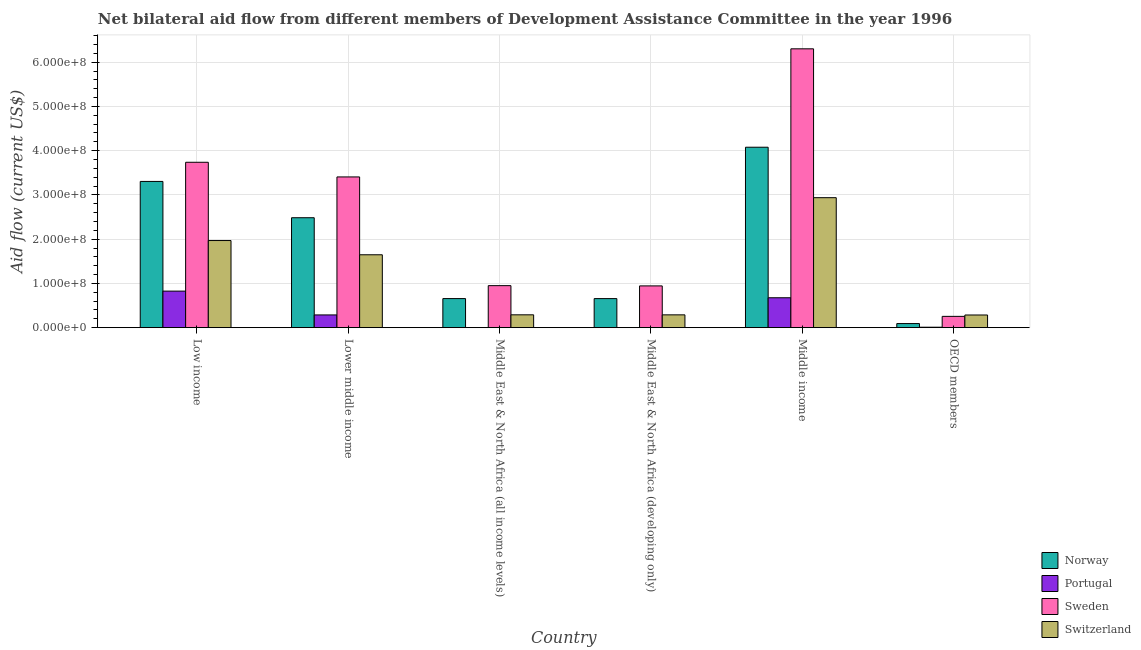How many different coloured bars are there?
Your answer should be very brief. 4. How many groups of bars are there?
Make the answer very short. 6. Are the number of bars per tick equal to the number of legend labels?
Make the answer very short. Yes. How many bars are there on the 5th tick from the left?
Make the answer very short. 4. How many bars are there on the 5th tick from the right?
Offer a terse response. 4. What is the label of the 5th group of bars from the left?
Your response must be concise. Middle income. What is the amount of aid given by switzerland in Middle income?
Give a very brief answer. 2.94e+08. Across all countries, what is the maximum amount of aid given by sweden?
Keep it short and to the point. 6.30e+08. Across all countries, what is the minimum amount of aid given by switzerland?
Offer a very short reply. 2.86e+07. In which country was the amount of aid given by portugal minimum?
Provide a succinct answer. Middle East & North Africa (all income levels). What is the total amount of aid given by sweden in the graph?
Offer a very short reply. 1.56e+09. What is the difference between the amount of aid given by sweden in Lower middle income and that in OECD members?
Provide a succinct answer. 3.15e+08. What is the difference between the amount of aid given by switzerland in Low income and the amount of aid given by norway in Middle East & North Africa (developing only)?
Your answer should be compact. 1.31e+08. What is the average amount of aid given by switzerland per country?
Your response must be concise. 1.24e+08. What is the difference between the amount of aid given by sweden and amount of aid given by norway in Lower middle income?
Ensure brevity in your answer.  9.22e+07. In how many countries, is the amount of aid given by sweden greater than 320000000 US$?
Your answer should be very brief. 3. What is the ratio of the amount of aid given by switzerland in Middle East & North Africa (all income levels) to that in OECD members?
Provide a succinct answer. 1.01. Is the difference between the amount of aid given by sweden in Middle East & North Africa (all income levels) and Middle income greater than the difference between the amount of aid given by switzerland in Middle East & North Africa (all income levels) and Middle income?
Offer a very short reply. No. What is the difference between the highest and the second highest amount of aid given by norway?
Provide a succinct answer. 7.73e+07. What is the difference between the highest and the lowest amount of aid given by norway?
Provide a short and direct response. 3.98e+08. Is it the case that in every country, the sum of the amount of aid given by switzerland and amount of aid given by portugal is greater than the sum of amount of aid given by norway and amount of aid given by sweden?
Offer a very short reply. No. What does the 1st bar from the left in Lower middle income represents?
Ensure brevity in your answer.  Norway. What does the 1st bar from the right in Low income represents?
Provide a short and direct response. Switzerland. How many bars are there?
Ensure brevity in your answer.  24. Are all the bars in the graph horizontal?
Offer a terse response. No. What is the difference between two consecutive major ticks on the Y-axis?
Your response must be concise. 1.00e+08. Are the values on the major ticks of Y-axis written in scientific E-notation?
Ensure brevity in your answer.  Yes. Does the graph contain grids?
Offer a terse response. Yes. Where does the legend appear in the graph?
Your response must be concise. Bottom right. How are the legend labels stacked?
Your response must be concise. Vertical. What is the title of the graph?
Your response must be concise. Net bilateral aid flow from different members of Development Assistance Committee in the year 1996. What is the Aid flow (current US$) of Norway in Low income?
Your answer should be compact. 3.30e+08. What is the Aid flow (current US$) in Portugal in Low income?
Ensure brevity in your answer.  8.26e+07. What is the Aid flow (current US$) of Sweden in Low income?
Give a very brief answer. 3.74e+08. What is the Aid flow (current US$) in Switzerland in Low income?
Your response must be concise. 1.97e+08. What is the Aid flow (current US$) of Norway in Lower middle income?
Make the answer very short. 2.48e+08. What is the Aid flow (current US$) of Portugal in Lower middle income?
Ensure brevity in your answer.  2.88e+07. What is the Aid flow (current US$) in Sweden in Lower middle income?
Your answer should be compact. 3.41e+08. What is the Aid flow (current US$) in Switzerland in Lower middle income?
Your answer should be compact. 1.65e+08. What is the Aid flow (current US$) in Norway in Middle East & North Africa (all income levels)?
Give a very brief answer. 6.57e+07. What is the Aid flow (current US$) in Sweden in Middle East & North Africa (all income levels)?
Offer a very short reply. 9.50e+07. What is the Aid flow (current US$) of Switzerland in Middle East & North Africa (all income levels)?
Make the answer very short. 2.90e+07. What is the Aid flow (current US$) in Norway in Middle East & North Africa (developing only)?
Provide a short and direct response. 6.57e+07. What is the Aid flow (current US$) in Portugal in Middle East & North Africa (developing only)?
Give a very brief answer. 2.20e+05. What is the Aid flow (current US$) in Sweden in Middle East & North Africa (developing only)?
Your answer should be compact. 9.44e+07. What is the Aid flow (current US$) of Switzerland in Middle East & North Africa (developing only)?
Make the answer very short. 2.90e+07. What is the Aid flow (current US$) of Norway in Middle income?
Keep it short and to the point. 4.08e+08. What is the Aid flow (current US$) in Portugal in Middle income?
Provide a succinct answer. 6.76e+07. What is the Aid flow (current US$) of Sweden in Middle income?
Keep it short and to the point. 6.30e+08. What is the Aid flow (current US$) of Switzerland in Middle income?
Keep it short and to the point. 2.94e+08. What is the Aid flow (current US$) in Norway in OECD members?
Ensure brevity in your answer.  9.26e+06. What is the Aid flow (current US$) in Portugal in OECD members?
Provide a succinct answer. 1.03e+06. What is the Aid flow (current US$) of Sweden in OECD members?
Keep it short and to the point. 2.55e+07. What is the Aid flow (current US$) in Switzerland in OECD members?
Give a very brief answer. 2.86e+07. Across all countries, what is the maximum Aid flow (current US$) of Norway?
Give a very brief answer. 4.08e+08. Across all countries, what is the maximum Aid flow (current US$) of Portugal?
Offer a very short reply. 8.26e+07. Across all countries, what is the maximum Aid flow (current US$) of Sweden?
Offer a very short reply. 6.30e+08. Across all countries, what is the maximum Aid flow (current US$) in Switzerland?
Your answer should be very brief. 2.94e+08. Across all countries, what is the minimum Aid flow (current US$) in Norway?
Ensure brevity in your answer.  9.26e+06. Across all countries, what is the minimum Aid flow (current US$) in Sweden?
Provide a succinct answer. 2.55e+07. Across all countries, what is the minimum Aid flow (current US$) of Switzerland?
Make the answer very short. 2.86e+07. What is the total Aid flow (current US$) in Norway in the graph?
Provide a short and direct response. 1.13e+09. What is the total Aid flow (current US$) in Portugal in the graph?
Provide a short and direct response. 1.80e+08. What is the total Aid flow (current US$) of Sweden in the graph?
Provide a succinct answer. 1.56e+09. What is the total Aid flow (current US$) in Switzerland in the graph?
Give a very brief answer. 7.42e+08. What is the difference between the Aid flow (current US$) of Norway in Low income and that in Lower middle income?
Your answer should be very brief. 8.20e+07. What is the difference between the Aid flow (current US$) of Portugal in Low income and that in Lower middle income?
Your response must be concise. 5.38e+07. What is the difference between the Aid flow (current US$) in Sweden in Low income and that in Lower middle income?
Your answer should be very brief. 3.32e+07. What is the difference between the Aid flow (current US$) of Switzerland in Low income and that in Lower middle income?
Your response must be concise. 3.22e+07. What is the difference between the Aid flow (current US$) of Norway in Low income and that in Middle East & North Africa (all income levels)?
Offer a very short reply. 2.65e+08. What is the difference between the Aid flow (current US$) of Portugal in Low income and that in Middle East & North Africa (all income levels)?
Offer a terse response. 8.24e+07. What is the difference between the Aid flow (current US$) of Sweden in Low income and that in Middle East & North Africa (all income levels)?
Make the answer very short. 2.79e+08. What is the difference between the Aid flow (current US$) of Switzerland in Low income and that in Middle East & North Africa (all income levels)?
Offer a very short reply. 1.68e+08. What is the difference between the Aid flow (current US$) in Norway in Low income and that in Middle East & North Africa (developing only)?
Provide a succinct answer. 2.65e+08. What is the difference between the Aid flow (current US$) of Portugal in Low income and that in Middle East & North Africa (developing only)?
Keep it short and to the point. 8.24e+07. What is the difference between the Aid flow (current US$) in Sweden in Low income and that in Middle East & North Africa (developing only)?
Offer a very short reply. 2.79e+08. What is the difference between the Aid flow (current US$) of Switzerland in Low income and that in Middle East & North Africa (developing only)?
Your response must be concise. 1.68e+08. What is the difference between the Aid flow (current US$) of Norway in Low income and that in Middle income?
Provide a short and direct response. -7.73e+07. What is the difference between the Aid flow (current US$) in Portugal in Low income and that in Middle income?
Give a very brief answer. 1.50e+07. What is the difference between the Aid flow (current US$) in Sweden in Low income and that in Middle income?
Make the answer very short. -2.56e+08. What is the difference between the Aid flow (current US$) in Switzerland in Low income and that in Middle income?
Offer a very short reply. -9.68e+07. What is the difference between the Aid flow (current US$) of Norway in Low income and that in OECD members?
Make the answer very short. 3.21e+08. What is the difference between the Aid flow (current US$) in Portugal in Low income and that in OECD members?
Provide a short and direct response. 8.16e+07. What is the difference between the Aid flow (current US$) of Sweden in Low income and that in OECD members?
Ensure brevity in your answer.  3.48e+08. What is the difference between the Aid flow (current US$) of Switzerland in Low income and that in OECD members?
Provide a succinct answer. 1.68e+08. What is the difference between the Aid flow (current US$) in Norway in Lower middle income and that in Middle East & North Africa (all income levels)?
Keep it short and to the point. 1.83e+08. What is the difference between the Aid flow (current US$) of Portugal in Lower middle income and that in Middle East & North Africa (all income levels)?
Provide a succinct answer. 2.86e+07. What is the difference between the Aid flow (current US$) in Sweden in Lower middle income and that in Middle East & North Africa (all income levels)?
Ensure brevity in your answer.  2.46e+08. What is the difference between the Aid flow (current US$) of Switzerland in Lower middle income and that in Middle East & North Africa (all income levels)?
Provide a succinct answer. 1.36e+08. What is the difference between the Aid flow (current US$) of Norway in Lower middle income and that in Middle East & North Africa (developing only)?
Ensure brevity in your answer.  1.83e+08. What is the difference between the Aid flow (current US$) of Portugal in Lower middle income and that in Middle East & North Africa (developing only)?
Make the answer very short. 2.86e+07. What is the difference between the Aid flow (current US$) of Sweden in Lower middle income and that in Middle East & North Africa (developing only)?
Give a very brief answer. 2.46e+08. What is the difference between the Aid flow (current US$) of Switzerland in Lower middle income and that in Middle East & North Africa (developing only)?
Ensure brevity in your answer.  1.36e+08. What is the difference between the Aid flow (current US$) in Norway in Lower middle income and that in Middle income?
Your answer should be compact. -1.59e+08. What is the difference between the Aid flow (current US$) in Portugal in Lower middle income and that in Middle income?
Your response must be concise. -3.88e+07. What is the difference between the Aid flow (current US$) in Sweden in Lower middle income and that in Middle income?
Provide a short and direct response. -2.90e+08. What is the difference between the Aid flow (current US$) in Switzerland in Lower middle income and that in Middle income?
Offer a very short reply. -1.29e+08. What is the difference between the Aid flow (current US$) of Norway in Lower middle income and that in OECD members?
Offer a terse response. 2.39e+08. What is the difference between the Aid flow (current US$) of Portugal in Lower middle income and that in OECD members?
Provide a short and direct response. 2.78e+07. What is the difference between the Aid flow (current US$) in Sweden in Lower middle income and that in OECD members?
Offer a terse response. 3.15e+08. What is the difference between the Aid flow (current US$) of Switzerland in Lower middle income and that in OECD members?
Provide a succinct answer. 1.36e+08. What is the difference between the Aid flow (current US$) of Norway in Middle East & North Africa (all income levels) and that in Middle East & North Africa (developing only)?
Your response must be concise. 3.00e+04. What is the difference between the Aid flow (current US$) in Sweden in Middle East & North Africa (all income levels) and that in Middle East & North Africa (developing only)?
Your answer should be compact. 5.60e+05. What is the difference between the Aid flow (current US$) of Switzerland in Middle East & North Africa (all income levels) and that in Middle East & North Africa (developing only)?
Your response must be concise. 4.00e+04. What is the difference between the Aid flow (current US$) of Norway in Middle East & North Africa (all income levels) and that in Middle income?
Provide a short and direct response. -3.42e+08. What is the difference between the Aid flow (current US$) of Portugal in Middle East & North Africa (all income levels) and that in Middle income?
Offer a terse response. -6.74e+07. What is the difference between the Aid flow (current US$) of Sweden in Middle East & North Africa (all income levels) and that in Middle income?
Make the answer very short. -5.35e+08. What is the difference between the Aid flow (current US$) of Switzerland in Middle East & North Africa (all income levels) and that in Middle income?
Ensure brevity in your answer.  -2.65e+08. What is the difference between the Aid flow (current US$) of Norway in Middle East & North Africa (all income levels) and that in OECD members?
Provide a succinct answer. 5.65e+07. What is the difference between the Aid flow (current US$) in Portugal in Middle East & North Africa (all income levels) and that in OECD members?
Ensure brevity in your answer.  -8.10e+05. What is the difference between the Aid flow (current US$) in Sweden in Middle East & North Africa (all income levels) and that in OECD members?
Provide a short and direct response. 6.94e+07. What is the difference between the Aid flow (current US$) of Switzerland in Middle East & North Africa (all income levels) and that in OECD members?
Your response must be concise. 3.60e+05. What is the difference between the Aid flow (current US$) in Norway in Middle East & North Africa (developing only) and that in Middle income?
Your answer should be very brief. -3.42e+08. What is the difference between the Aid flow (current US$) in Portugal in Middle East & North Africa (developing only) and that in Middle income?
Keep it short and to the point. -6.74e+07. What is the difference between the Aid flow (current US$) in Sweden in Middle East & North Africa (developing only) and that in Middle income?
Give a very brief answer. -5.36e+08. What is the difference between the Aid flow (current US$) in Switzerland in Middle East & North Africa (developing only) and that in Middle income?
Make the answer very short. -2.65e+08. What is the difference between the Aid flow (current US$) of Norway in Middle East & North Africa (developing only) and that in OECD members?
Your answer should be very brief. 5.64e+07. What is the difference between the Aid flow (current US$) in Portugal in Middle East & North Africa (developing only) and that in OECD members?
Your response must be concise. -8.10e+05. What is the difference between the Aid flow (current US$) of Sweden in Middle East & North Africa (developing only) and that in OECD members?
Give a very brief answer. 6.89e+07. What is the difference between the Aid flow (current US$) in Switzerland in Middle East & North Africa (developing only) and that in OECD members?
Offer a terse response. 3.20e+05. What is the difference between the Aid flow (current US$) in Norway in Middle income and that in OECD members?
Keep it short and to the point. 3.98e+08. What is the difference between the Aid flow (current US$) of Portugal in Middle income and that in OECD members?
Your answer should be compact. 6.66e+07. What is the difference between the Aid flow (current US$) of Sweden in Middle income and that in OECD members?
Provide a short and direct response. 6.05e+08. What is the difference between the Aid flow (current US$) in Switzerland in Middle income and that in OECD members?
Offer a very short reply. 2.65e+08. What is the difference between the Aid flow (current US$) of Norway in Low income and the Aid flow (current US$) of Portugal in Lower middle income?
Your answer should be very brief. 3.02e+08. What is the difference between the Aid flow (current US$) of Norway in Low income and the Aid flow (current US$) of Sweden in Lower middle income?
Provide a succinct answer. -1.01e+07. What is the difference between the Aid flow (current US$) of Norway in Low income and the Aid flow (current US$) of Switzerland in Lower middle income?
Give a very brief answer. 1.66e+08. What is the difference between the Aid flow (current US$) of Portugal in Low income and the Aid flow (current US$) of Sweden in Lower middle income?
Offer a terse response. -2.58e+08. What is the difference between the Aid flow (current US$) in Portugal in Low income and the Aid flow (current US$) in Switzerland in Lower middle income?
Keep it short and to the point. -8.21e+07. What is the difference between the Aid flow (current US$) of Sweden in Low income and the Aid flow (current US$) of Switzerland in Lower middle income?
Offer a very short reply. 2.09e+08. What is the difference between the Aid flow (current US$) of Norway in Low income and the Aid flow (current US$) of Portugal in Middle East & North Africa (all income levels)?
Your response must be concise. 3.30e+08. What is the difference between the Aid flow (current US$) in Norway in Low income and the Aid flow (current US$) in Sweden in Middle East & North Africa (all income levels)?
Offer a terse response. 2.36e+08. What is the difference between the Aid flow (current US$) of Norway in Low income and the Aid flow (current US$) of Switzerland in Middle East & North Africa (all income levels)?
Ensure brevity in your answer.  3.01e+08. What is the difference between the Aid flow (current US$) of Portugal in Low income and the Aid flow (current US$) of Sweden in Middle East & North Africa (all income levels)?
Your answer should be compact. -1.24e+07. What is the difference between the Aid flow (current US$) of Portugal in Low income and the Aid flow (current US$) of Switzerland in Middle East & North Africa (all income levels)?
Make the answer very short. 5.36e+07. What is the difference between the Aid flow (current US$) of Sweden in Low income and the Aid flow (current US$) of Switzerland in Middle East & North Africa (all income levels)?
Make the answer very short. 3.45e+08. What is the difference between the Aid flow (current US$) in Norway in Low income and the Aid flow (current US$) in Portugal in Middle East & North Africa (developing only)?
Give a very brief answer. 3.30e+08. What is the difference between the Aid flow (current US$) in Norway in Low income and the Aid flow (current US$) in Sweden in Middle East & North Africa (developing only)?
Provide a succinct answer. 2.36e+08. What is the difference between the Aid flow (current US$) in Norway in Low income and the Aid flow (current US$) in Switzerland in Middle East & North Africa (developing only)?
Make the answer very short. 3.02e+08. What is the difference between the Aid flow (current US$) of Portugal in Low income and the Aid flow (current US$) of Sweden in Middle East & North Africa (developing only)?
Your answer should be compact. -1.18e+07. What is the difference between the Aid flow (current US$) in Portugal in Low income and the Aid flow (current US$) in Switzerland in Middle East & North Africa (developing only)?
Provide a short and direct response. 5.36e+07. What is the difference between the Aid flow (current US$) in Sweden in Low income and the Aid flow (current US$) in Switzerland in Middle East & North Africa (developing only)?
Your answer should be very brief. 3.45e+08. What is the difference between the Aid flow (current US$) in Norway in Low income and the Aid flow (current US$) in Portugal in Middle income?
Provide a short and direct response. 2.63e+08. What is the difference between the Aid flow (current US$) of Norway in Low income and the Aid flow (current US$) of Sweden in Middle income?
Your answer should be compact. -3.00e+08. What is the difference between the Aid flow (current US$) in Norway in Low income and the Aid flow (current US$) in Switzerland in Middle income?
Your answer should be compact. 3.68e+07. What is the difference between the Aid flow (current US$) of Portugal in Low income and the Aid flow (current US$) of Sweden in Middle income?
Give a very brief answer. -5.48e+08. What is the difference between the Aid flow (current US$) of Portugal in Low income and the Aid flow (current US$) of Switzerland in Middle income?
Provide a short and direct response. -2.11e+08. What is the difference between the Aid flow (current US$) in Sweden in Low income and the Aid flow (current US$) in Switzerland in Middle income?
Ensure brevity in your answer.  8.00e+07. What is the difference between the Aid flow (current US$) in Norway in Low income and the Aid flow (current US$) in Portugal in OECD members?
Ensure brevity in your answer.  3.29e+08. What is the difference between the Aid flow (current US$) of Norway in Low income and the Aid flow (current US$) of Sweden in OECD members?
Your response must be concise. 3.05e+08. What is the difference between the Aid flow (current US$) of Norway in Low income and the Aid flow (current US$) of Switzerland in OECD members?
Give a very brief answer. 3.02e+08. What is the difference between the Aid flow (current US$) of Portugal in Low income and the Aid flow (current US$) of Sweden in OECD members?
Provide a short and direct response. 5.71e+07. What is the difference between the Aid flow (current US$) in Portugal in Low income and the Aid flow (current US$) in Switzerland in OECD members?
Ensure brevity in your answer.  5.39e+07. What is the difference between the Aid flow (current US$) of Sweden in Low income and the Aid flow (current US$) of Switzerland in OECD members?
Provide a succinct answer. 3.45e+08. What is the difference between the Aid flow (current US$) of Norway in Lower middle income and the Aid flow (current US$) of Portugal in Middle East & North Africa (all income levels)?
Make the answer very short. 2.48e+08. What is the difference between the Aid flow (current US$) of Norway in Lower middle income and the Aid flow (current US$) of Sweden in Middle East & North Africa (all income levels)?
Keep it short and to the point. 1.53e+08. What is the difference between the Aid flow (current US$) in Norway in Lower middle income and the Aid flow (current US$) in Switzerland in Middle East & North Africa (all income levels)?
Offer a terse response. 2.19e+08. What is the difference between the Aid flow (current US$) of Portugal in Lower middle income and the Aid flow (current US$) of Sweden in Middle East & North Africa (all income levels)?
Offer a terse response. -6.62e+07. What is the difference between the Aid flow (current US$) of Portugal in Lower middle income and the Aid flow (current US$) of Switzerland in Middle East & North Africa (all income levels)?
Offer a very short reply. -2.20e+05. What is the difference between the Aid flow (current US$) in Sweden in Lower middle income and the Aid flow (current US$) in Switzerland in Middle East & North Africa (all income levels)?
Provide a short and direct response. 3.12e+08. What is the difference between the Aid flow (current US$) in Norway in Lower middle income and the Aid flow (current US$) in Portugal in Middle East & North Africa (developing only)?
Provide a succinct answer. 2.48e+08. What is the difference between the Aid flow (current US$) in Norway in Lower middle income and the Aid flow (current US$) in Sweden in Middle East & North Africa (developing only)?
Offer a very short reply. 1.54e+08. What is the difference between the Aid flow (current US$) in Norway in Lower middle income and the Aid flow (current US$) in Switzerland in Middle East & North Africa (developing only)?
Provide a succinct answer. 2.19e+08. What is the difference between the Aid flow (current US$) of Portugal in Lower middle income and the Aid flow (current US$) of Sweden in Middle East & North Africa (developing only)?
Provide a succinct answer. -6.56e+07. What is the difference between the Aid flow (current US$) in Sweden in Lower middle income and the Aid flow (current US$) in Switzerland in Middle East & North Africa (developing only)?
Offer a terse response. 3.12e+08. What is the difference between the Aid flow (current US$) of Norway in Lower middle income and the Aid flow (current US$) of Portugal in Middle income?
Your response must be concise. 1.81e+08. What is the difference between the Aid flow (current US$) of Norway in Lower middle income and the Aid flow (current US$) of Sweden in Middle income?
Your response must be concise. -3.82e+08. What is the difference between the Aid flow (current US$) in Norway in Lower middle income and the Aid flow (current US$) in Switzerland in Middle income?
Give a very brief answer. -4.53e+07. What is the difference between the Aid flow (current US$) of Portugal in Lower middle income and the Aid flow (current US$) of Sweden in Middle income?
Your response must be concise. -6.01e+08. What is the difference between the Aid flow (current US$) in Portugal in Lower middle income and the Aid flow (current US$) in Switzerland in Middle income?
Provide a succinct answer. -2.65e+08. What is the difference between the Aid flow (current US$) in Sweden in Lower middle income and the Aid flow (current US$) in Switzerland in Middle income?
Provide a succinct answer. 4.69e+07. What is the difference between the Aid flow (current US$) of Norway in Lower middle income and the Aid flow (current US$) of Portugal in OECD members?
Give a very brief answer. 2.47e+08. What is the difference between the Aid flow (current US$) of Norway in Lower middle income and the Aid flow (current US$) of Sweden in OECD members?
Provide a succinct answer. 2.23e+08. What is the difference between the Aid flow (current US$) of Norway in Lower middle income and the Aid flow (current US$) of Switzerland in OECD members?
Provide a succinct answer. 2.20e+08. What is the difference between the Aid flow (current US$) in Portugal in Lower middle income and the Aid flow (current US$) in Sweden in OECD members?
Offer a very short reply. 3.26e+06. What is the difference between the Aid flow (current US$) of Sweden in Lower middle income and the Aid flow (current US$) of Switzerland in OECD members?
Provide a succinct answer. 3.12e+08. What is the difference between the Aid flow (current US$) of Norway in Middle East & North Africa (all income levels) and the Aid flow (current US$) of Portugal in Middle East & North Africa (developing only)?
Make the answer very short. 6.55e+07. What is the difference between the Aid flow (current US$) in Norway in Middle East & North Africa (all income levels) and the Aid flow (current US$) in Sweden in Middle East & North Africa (developing only)?
Offer a very short reply. -2.87e+07. What is the difference between the Aid flow (current US$) of Norway in Middle East & North Africa (all income levels) and the Aid flow (current US$) of Switzerland in Middle East & North Africa (developing only)?
Provide a succinct answer. 3.68e+07. What is the difference between the Aid flow (current US$) in Portugal in Middle East & North Africa (all income levels) and the Aid flow (current US$) in Sweden in Middle East & North Africa (developing only)?
Keep it short and to the point. -9.42e+07. What is the difference between the Aid flow (current US$) of Portugal in Middle East & North Africa (all income levels) and the Aid flow (current US$) of Switzerland in Middle East & North Africa (developing only)?
Offer a very short reply. -2.88e+07. What is the difference between the Aid flow (current US$) of Sweden in Middle East & North Africa (all income levels) and the Aid flow (current US$) of Switzerland in Middle East & North Africa (developing only)?
Your answer should be very brief. 6.60e+07. What is the difference between the Aid flow (current US$) in Norway in Middle East & North Africa (all income levels) and the Aid flow (current US$) in Portugal in Middle income?
Ensure brevity in your answer.  -1.87e+06. What is the difference between the Aid flow (current US$) of Norway in Middle East & North Africa (all income levels) and the Aid flow (current US$) of Sweden in Middle income?
Offer a terse response. -5.64e+08. What is the difference between the Aid flow (current US$) of Norway in Middle East & North Africa (all income levels) and the Aid flow (current US$) of Switzerland in Middle income?
Provide a succinct answer. -2.28e+08. What is the difference between the Aid flow (current US$) in Portugal in Middle East & North Africa (all income levels) and the Aid flow (current US$) in Sweden in Middle income?
Provide a short and direct response. -6.30e+08. What is the difference between the Aid flow (current US$) in Portugal in Middle East & North Africa (all income levels) and the Aid flow (current US$) in Switzerland in Middle income?
Your response must be concise. -2.94e+08. What is the difference between the Aid flow (current US$) in Sweden in Middle East & North Africa (all income levels) and the Aid flow (current US$) in Switzerland in Middle income?
Give a very brief answer. -1.99e+08. What is the difference between the Aid flow (current US$) of Norway in Middle East & North Africa (all income levels) and the Aid flow (current US$) of Portugal in OECD members?
Your response must be concise. 6.47e+07. What is the difference between the Aid flow (current US$) of Norway in Middle East & North Africa (all income levels) and the Aid flow (current US$) of Sweden in OECD members?
Offer a terse response. 4.02e+07. What is the difference between the Aid flow (current US$) of Norway in Middle East & North Africa (all income levels) and the Aid flow (current US$) of Switzerland in OECD members?
Offer a very short reply. 3.71e+07. What is the difference between the Aid flow (current US$) in Portugal in Middle East & North Africa (all income levels) and the Aid flow (current US$) in Sweden in OECD members?
Keep it short and to the point. -2.53e+07. What is the difference between the Aid flow (current US$) of Portugal in Middle East & North Africa (all income levels) and the Aid flow (current US$) of Switzerland in OECD members?
Provide a succinct answer. -2.84e+07. What is the difference between the Aid flow (current US$) of Sweden in Middle East & North Africa (all income levels) and the Aid flow (current US$) of Switzerland in OECD members?
Offer a very short reply. 6.63e+07. What is the difference between the Aid flow (current US$) of Norway in Middle East & North Africa (developing only) and the Aid flow (current US$) of Portugal in Middle income?
Provide a succinct answer. -1.90e+06. What is the difference between the Aid flow (current US$) in Norway in Middle East & North Africa (developing only) and the Aid flow (current US$) in Sweden in Middle income?
Your answer should be very brief. -5.64e+08. What is the difference between the Aid flow (current US$) in Norway in Middle East & North Africa (developing only) and the Aid flow (current US$) in Switzerland in Middle income?
Provide a short and direct response. -2.28e+08. What is the difference between the Aid flow (current US$) in Portugal in Middle East & North Africa (developing only) and the Aid flow (current US$) in Sweden in Middle income?
Give a very brief answer. -6.30e+08. What is the difference between the Aid flow (current US$) in Portugal in Middle East & North Africa (developing only) and the Aid flow (current US$) in Switzerland in Middle income?
Make the answer very short. -2.94e+08. What is the difference between the Aid flow (current US$) in Sweden in Middle East & North Africa (developing only) and the Aid flow (current US$) in Switzerland in Middle income?
Offer a terse response. -1.99e+08. What is the difference between the Aid flow (current US$) of Norway in Middle East & North Africa (developing only) and the Aid flow (current US$) of Portugal in OECD members?
Make the answer very short. 6.47e+07. What is the difference between the Aid flow (current US$) of Norway in Middle East & North Africa (developing only) and the Aid flow (current US$) of Sweden in OECD members?
Offer a terse response. 4.02e+07. What is the difference between the Aid flow (current US$) of Norway in Middle East & North Africa (developing only) and the Aid flow (current US$) of Switzerland in OECD members?
Your answer should be compact. 3.70e+07. What is the difference between the Aid flow (current US$) of Portugal in Middle East & North Africa (developing only) and the Aid flow (current US$) of Sweden in OECD members?
Your answer should be very brief. -2.53e+07. What is the difference between the Aid flow (current US$) in Portugal in Middle East & North Africa (developing only) and the Aid flow (current US$) in Switzerland in OECD members?
Keep it short and to the point. -2.84e+07. What is the difference between the Aid flow (current US$) in Sweden in Middle East & North Africa (developing only) and the Aid flow (current US$) in Switzerland in OECD members?
Give a very brief answer. 6.58e+07. What is the difference between the Aid flow (current US$) of Norway in Middle income and the Aid flow (current US$) of Portugal in OECD members?
Keep it short and to the point. 4.07e+08. What is the difference between the Aid flow (current US$) in Norway in Middle income and the Aid flow (current US$) in Sweden in OECD members?
Your response must be concise. 3.82e+08. What is the difference between the Aid flow (current US$) in Norway in Middle income and the Aid flow (current US$) in Switzerland in OECD members?
Offer a very short reply. 3.79e+08. What is the difference between the Aid flow (current US$) of Portugal in Middle income and the Aid flow (current US$) of Sweden in OECD members?
Ensure brevity in your answer.  4.21e+07. What is the difference between the Aid flow (current US$) of Portugal in Middle income and the Aid flow (current US$) of Switzerland in OECD members?
Your answer should be very brief. 3.89e+07. What is the difference between the Aid flow (current US$) in Sweden in Middle income and the Aid flow (current US$) in Switzerland in OECD members?
Your response must be concise. 6.02e+08. What is the average Aid flow (current US$) of Norway per country?
Offer a very short reply. 1.88e+08. What is the average Aid flow (current US$) of Portugal per country?
Your response must be concise. 3.01e+07. What is the average Aid flow (current US$) in Sweden per country?
Make the answer very short. 2.60e+08. What is the average Aid flow (current US$) of Switzerland per country?
Keep it short and to the point. 1.24e+08. What is the difference between the Aid flow (current US$) in Norway and Aid flow (current US$) in Portugal in Low income?
Your response must be concise. 2.48e+08. What is the difference between the Aid flow (current US$) of Norway and Aid flow (current US$) of Sweden in Low income?
Keep it short and to the point. -4.33e+07. What is the difference between the Aid flow (current US$) in Norway and Aid flow (current US$) in Switzerland in Low income?
Give a very brief answer. 1.34e+08. What is the difference between the Aid flow (current US$) in Portugal and Aid flow (current US$) in Sweden in Low income?
Your response must be concise. -2.91e+08. What is the difference between the Aid flow (current US$) of Portugal and Aid flow (current US$) of Switzerland in Low income?
Your answer should be very brief. -1.14e+08. What is the difference between the Aid flow (current US$) of Sweden and Aid flow (current US$) of Switzerland in Low income?
Offer a very short reply. 1.77e+08. What is the difference between the Aid flow (current US$) in Norway and Aid flow (current US$) in Portugal in Lower middle income?
Offer a very short reply. 2.20e+08. What is the difference between the Aid flow (current US$) in Norway and Aid flow (current US$) in Sweden in Lower middle income?
Offer a terse response. -9.22e+07. What is the difference between the Aid flow (current US$) in Norway and Aid flow (current US$) in Switzerland in Lower middle income?
Provide a succinct answer. 8.37e+07. What is the difference between the Aid flow (current US$) of Portugal and Aid flow (current US$) of Sweden in Lower middle income?
Provide a short and direct response. -3.12e+08. What is the difference between the Aid flow (current US$) in Portugal and Aid flow (current US$) in Switzerland in Lower middle income?
Make the answer very short. -1.36e+08. What is the difference between the Aid flow (current US$) of Sweden and Aid flow (current US$) of Switzerland in Lower middle income?
Keep it short and to the point. 1.76e+08. What is the difference between the Aid flow (current US$) in Norway and Aid flow (current US$) in Portugal in Middle East & North Africa (all income levels)?
Provide a succinct answer. 6.55e+07. What is the difference between the Aid flow (current US$) of Norway and Aid flow (current US$) of Sweden in Middle East & North Africa (all income levels)?
Keep it short and to the point. -2.92e+07. What is the difference between the Aid flow (current US$) in Norway and Aid flow (current US$) in Switzerland in Middle East & North Africa (all income levels)?
Your response must be concise. 3.67e+07. What is the difference between the Aid flow (current US$) of Portugal and Aid flow (current US$) of Sweden in Middle East & North Africa (all income levels)?
Provide a succinct answer. -9.47e+07. What is the difference between the Aid flow (current US$) in Portugal and Aid flow (current US$) in Switzerland in Middle East & North Africa (all income levels)?
Your answer should be very brief. -2.88e+07. What is the difference between the Aid flow (current US$) in Sweden and Aid flow (current US$) in Switzerland in Middle East & North Africa (all income levels)?
Your response must be concise. 6.60e+07. What is the difference between the Aid flow (current US$) of Norway and Aid flow (current US$) of Portugal in Middle East & North Africa (developing only)?
Give a very brief answer. 6.55e+07. What is the difference between the Aid flow (current US$) in Norway and Aid flow (current US$) in Sweden in Middle East & North Africa (developing only)?
Your answer should be very brief. -2.87e+07. What is the difference between the Aid flow (current US$) in Norway and Aid flow (current US$) in Switzerland in Middle East & North Africa (developing only)?
Provide a short and direct response. 3.67e+07. What is the difference between the Aid flow (current US$) of Portugal and Aid flow (current US$) of Sweden in Middle East & North Africa (developing only)?
Keep it short and to the point. -9.42e+07. What is the difference between the Aid flow (current US$) in Portugal and Aid flow (current US$) in Switzerland in Middle East & North Africa (developing only)?
Your answer should be very brief. -2.88e+07. What is the difference between the Aid flow (current US$) of Sweden and Aid flow (current US$) of Switzerland in Middle East & North Africa (developing only)?
Offer a terse response. 6.54e+07. What is the difference between the Aid flow (current US$) in Norway and Aid flow (current US$) in Portugal in Middle income?
Keep it short and to the point. 3.40e+08. What is the difference between the Aid flow (current US$) of Norway and Aid flow (current US$) of Sweden in Middle income?
Ensure brevity in your answer.  -2.22e+08. What is the difference between the Aid flow (current US$) in Norway and Aid flow (current US$) in Switzerland in Middle income?
Keep it short and to the point. 1.14e+08. What is the difference between the Aid flow (current US$) of Portugal and Aid flow (current US$) of Sweden in Middle income?
Give a very brief answer. -5.63e+08. What is the difference between the Aid flow (current US$) in Portugal and Aid flow (current US$) in Switzerland in Middle income?
Keep it short and to the point. -2.26e+08. What is the difference between the Aid flow (current US$) of Sweden and Aid flow (current US$) of Switzerland in Middle income?
Offer a very short reply. 3.36e+08. What is the difference between the Aid flow (current US$) of Norway and Aid flow (current US$) of Portugal in OECD members?
Provide a short and direct response. 8.23e+06. What is the difference between the Aid flow (current US$) in Norway and Aid flow (current US$) in Sweden in OECD members?
Your answer should be compact. -1.63e+07. What is the difference between the Aid flow (current US$) of Norway and Aid flow (current US$) of Switzerland in OECD members?
Offer a terse response. -1.94e+07. What is the difference between the Aid flow (current US$) of Portugal and Aid flow (current US$) of Sweden in OECD members?
Make the answer very short. -2.45e+07. What is the difference between the Aid flow (current US$) in Portugal and Aid flow (current US$) in Switzerland in OECD members?
Give a very brief answer. -2.76e+07. What is the difference between the Aid flow (current US$) in Sweden and Aid flow (current US$) in Switzerland in OECD members?
Your answer should be compact. -3.12e+06. What is the ratio of the Aid flow (current US$) in Norway in Low income to that in Lower middle income?
Make the answer very short. 1.33. What is the ratio of the Aid flow (current US$) in Portugal in Low income to that in Lower middle income?
Your answer should be very brief. 2.87. What is the ratio of the Aid flow (current US$) in Sweden in Low income to that in Lower middle income?
Your answer should be compact. 1.1. What is the ratio of the Aid flow (current US$) of Switzerland in Low income to that in Lower middle income?
Make the answer very short. 1.2. What is the ratio of the Aid flow (current US$) in Norway in Low income to that in Middle East & North Africa (all income levels)?
Give a very brief answer. 5.03. What is the ratio of the Aid flow (current US$) of Portugal in Low income to that in Middle East & North Africa (all income levels)?
Offer a very short reply. 375.41. What is the ratio of the Aid flow (current US$) in Sweden in Low income to that in Middle East & North Africa (all income levels)?
Your response must be concise. 3.94. What is the ratio of the Aid flow (current US$) in Switzerland in Low income to that in Middle East & North Africa (all income levels)?
Ensure brevity in your answer.  6.79. What is the ratio of the Aid flow (current US$) in Norway in Low income to that in Middle East & North Africa (developing only)?
Your response must be concise. 5.03. What is the ratio of the Aid flow (current US$) in Portugal in Low income to that in Middle East & North Africa (developing only)?
Your answer should be very brief. 375.41. What is the ratio of the Aid flow (current US$) in Sweden in Low income to that in Middle East & North Africa (developing only)?
Keep it short and to the point. 3.96. What is the ratio of the Aid flow (current US$) of Switzerland in Low income to that in Middle East & North Africa (developing only)?
Offer a very short reply. 6.8. What is the ratio of the Aid flow (current US$) in Norway in Low income to that in Middle income?
Make the answer very short. 0.81. What is the ratio of the Aid flow (current US$) of Portugal in Low income to that in Middle income?
Ensure brevity in your answer.  1.22. What is the ratio of the Aid flow (current US$) in Sweden in Low income to that in Middle income?
Ensure brevity in your answer.  0.59. What is the ratio of the Aid flow (current US$) of Switzerland in Low income to that in Middle income?
Your response must be concise. 0.67. What is the ratio of the Aid flow (current US$) in Norway in Low income to that in OECD members?
Keep it short and to the point. 35.69. What is the ratio of the Aid flow (current US$) of Portugal in Low income to that in OECD members?
Keep it short and to the point. 80.18. What is the ratio of the Aid flow (current US$) in Sweden in Low income to that in OECD members?
Provide a succinct answer. 14.64. What is the ratio of the Aid flow (current US$) in Switzerland in Low income to that in OECD members?
Offer a terse response. 6.87. What is the ratio of the Aid flow (current US$) in Norway in Lower middle income to that in Middle East & North Africa (all income levels)?
Provide a short and direct response. 3.78. What is the ratio of the Aid flow (current US$) of Portugal in Lower middle income to that in Middle East & North Africa (all income levels)?
Provide a short and direct response. 130.86. What is the ratio of the Aid flow (current US$) of Sweden in Lower middle income to that in Middle East & North Africa (all income levels)?
Provide a short and direct response. 3.59. What is the ratio of the Aid flow (current US$) of Switzerland in Lower middle income to that in Middle East & North Africa (all income levels)?
Give a very brief answer. 5.68. What is the ratio of the Aid flow (current US$) of Norway in Lower middle income to that in Middle East & North Africa (developing only)?
Your answer should be compact. 3.78. What is the ratio of the Aid flow (current US$) of Portugal in Lower middle income to that in Middle East & North Africa (developing only)?
Offer a very short reply. 130.86. What is the ratio of the Aid flow (current US$) of Sweden in Lower middle income to that in Middle East & North Africa (developing only)?
Your answer should be compact. 3.61. What is the ratio of the Aid flow (current US$) in Switzerland in Lower middle income to that in Middle East & North Africa (developing only)?
Ensure brevity in your answer.  5.69. What is the ratio of the Aid flow (current US$) of Norway in Lower middle income to that in Middle income?
Offer a very short reply. 0.61. What is the ratio of the Aid flow (current US$) in Portugal in Lower middle income to that in Middle income?
Make the answer very short. 0.43. What is the ratio of the Aid flow (current US$) in Sweden in Lower middle income to that in Middle income?
Your answer should be very brief. 0.54. What is the ratio of the Aid flow (current US$) of Switzerland in Lower middle income to that in Middle income?
Offer a very short reply. 0.56. What is the ratio of the Aid flow (current US$) in Norway in Lower middle income to that in OECD members?
Your answer should be very brief. 26.83. What is the ratio of the Aid flow (current US$) in Portugal in Lower middle income to that in OECD members?
Give a very brief answer. 27.95. What is the ratio of the Aid flow (current US$) in Sweden in Lower middle income to that in OECD members?
Provide a short and direct response. 13.34. What is the ratio of the Aid flow (current US$) in Switzerland in Lower middle income to that in OECD members?
Ensure brevity in your answer.  5.75. What is the ratio of the Aid flow (current US$) of Norway in Middle East & North Africa (all income levels) to that in Middle East & North Africa (developing only)?
Offer a terse response. 1. What is the ratio of the Aid flow (current US$) of Sweden in Middle East & North Africa (all income levels) to that in Middle East & North Africa (developing only)?
Provide a short and direct response. 1.01. What is the ratio of the Aid flow (current US$) in Norway in Middle East & North Africa (all income levels) to that in Middle income?
Make the answer very short. 0.16. What is the ratio of the Aid flow (current US$) in Portugal in Middle East & North Africa (all income levels) to that in Middle income?
Provide a succinct answer. 0. What is the ratio of the Aid flow (current US$) of Sweden in Middle East & North Africa (all income levels) to that in Middle income?
Offer a very short reply. 0.15. What is the ratio of the Aid flow (current US$) in Switzerland in Middle East & North Africa (all income levels) to that in Middle income?
Make the answer very short. 0.1. What is the ratio of the Aid flow (current US$) of Norway in Middle East & North Africa (all income levels) to that in OECD members?
Give a very brief answer. 7.1. What is the ratio of the Aid flow (current US$) in Portugal in Middle East & North Africa (all income levels) to that in OECD members?
Provide a succinct answer. 0.21. What is the ratio of the Aid flow (current US$) of Sweden in Middle East & North Africa (all income levels) to that in OECD members?
Provide a succinct answer. 3.72. What is the ratio of the Aid flow (current US$) of Switzerland in Middle East & North Africa (all income levels) to that in OECD members?
Provide a short and direct response. 1.01. What is the ratio of the Aid flow (current US$) in Norway in Middle East & North Africa (developing only) to that in Middle income?
Offer a very short reply. 0.16. What is the ratio of the Aid flow (current US$) in Portugal in Middle East & North Africa (developing only) to that in Middle income?
Your answer should be very brief. 0. What is the ratio of the Aid flow (current US$) of Sweden in Middle East & North Africa (developing only) to that in Middle income?
Offer a very short reply. 0.15. What is the ratio of the Aid flow (current US$) in Switzerland in Middle East & North Africa (developing only) to that in Middle income?
Your answer should be compact. 0.1. What is the ratio of the Aid flow (current US$) in Norway in Middle East & North Africa (developing only) to that in OECD members?
Offer a terse response. 7.09. What is the ratio of the Aid flow (current US$) of Portugal in Middle East & North Africa (developing only) to that in OECD members?
Your answer should be very brief. 0.21. What is the ratio of the Aid flow (current US$) of Sweden in Middle East & North Africa (developing only) to that in OECD members?
Offer a terse response. 3.7. What is the ratio of the Aid flow (current US$) in Switzerland in Middle East & North Africa (developing only) to that in OECD members?
Provide a succinct answer. 1.01. What is the ratio of the Aid flow (current US$) in Norway in Middle income to that in OECD members?
Keep it short and to the point. 44.03. What is the ratio of the Aid flow (current US$) of Portugal in Middle income to that in OECD members?
Your response must be concise. 65.62. What is the ratio of the Aid flow (current US$) of Sweden in Middle income to that in OECD members?
Offer a very short reply. 24.68. What is the ratio of the Aid flow (current US$) in Switzerland in Middle income to that in OECD members?
Provide a succinct answer. 10.25. What is the difference between the highest and the second highest Aid flow (current US$) in Norway?
Give a very brief answer. 7.73e+07. What is the difference between the highest and the second highest Aid flow (current US$) of Portugal?
Give a very brief answer. 1.50e+07. What is the difference between the highest and the second highest Aid flow (current US$) in Sweden?
Your answer should be very brief. 2.56e+08. What is the difference between the highest and the second highest Aid flow (current US$) in Switzerland?
Provide a succinct answer. 9.68e+07. What is the difference between the highest and the lowest Aid flow (current US$) of Norway?
Ensure brevity in your answer.  3.98e+08. What is the difference between the highest and the lowest Aid flow (current US$) of Portugal?
Give a very brief answer. 8.24e+07. What is the difference between the highest and the lowest Aid flow (current US$) in Sweden?
Give a very brief answer. 6.05e+08. What is the difference between the highest and the lowest Aid flow (current US$) of Switzerland?
Your response must be concise. 2.65e+08. 